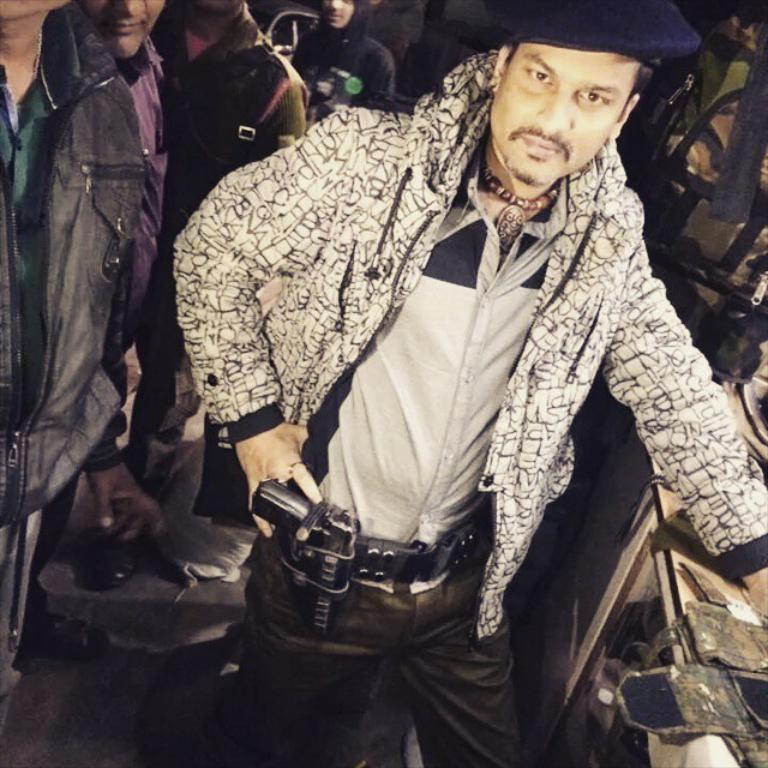What is the main subject of the image? There is a man in the image. What is the man wearing on his head? The man is wearing a cap. What type of clothing is the man wearing on his upper body? The man is wearing a jacket. What surface is the man standing on? The man is standing on the floor. What object can be seen in the image? There is a gun in the image. What else can be seen in the background of the image? There are people and objects visible in the background of the image. What holiday is being celebrated in the image? There is no indication of a holiday being celebrated in the image. What level of difficulty is the man attempting in the image? There is no indication of any difficulty level or challenge being depicted in the image. 